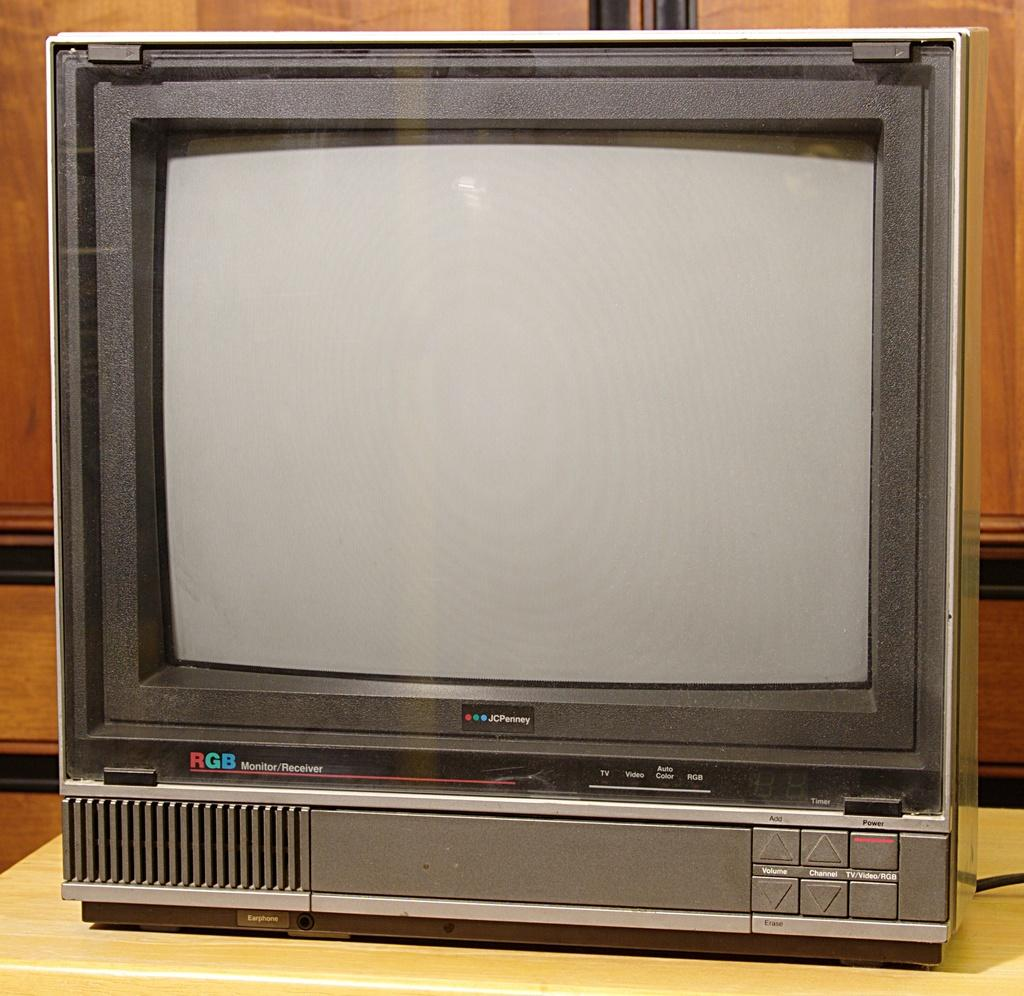<image>
Summarize the visual content of the image. An old JCPenny television with a VCR built in. 